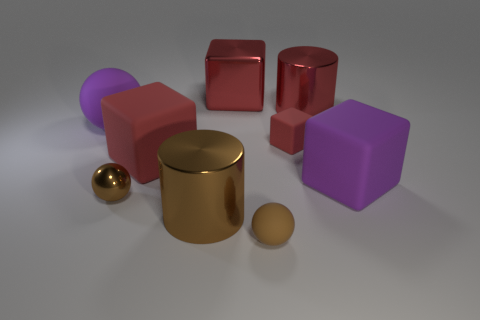Subtract all blue cylinders. How many red blocks are left? 3 Subtract all blue cubes. Subtract all yellow cylinders. How many cubes are left? 4 Subtract all cylinders. How many objects are left? 7 Subtract all big red rubber cubes. Subtract all purple things. How many objects are left? 6 Add 5 large red things. How many large red things are left? 8 Add 5 big red metal cylinders. How many big red metal cylinders exist? 6 Subtract 0 green cylinders. How many objects are left? 9 